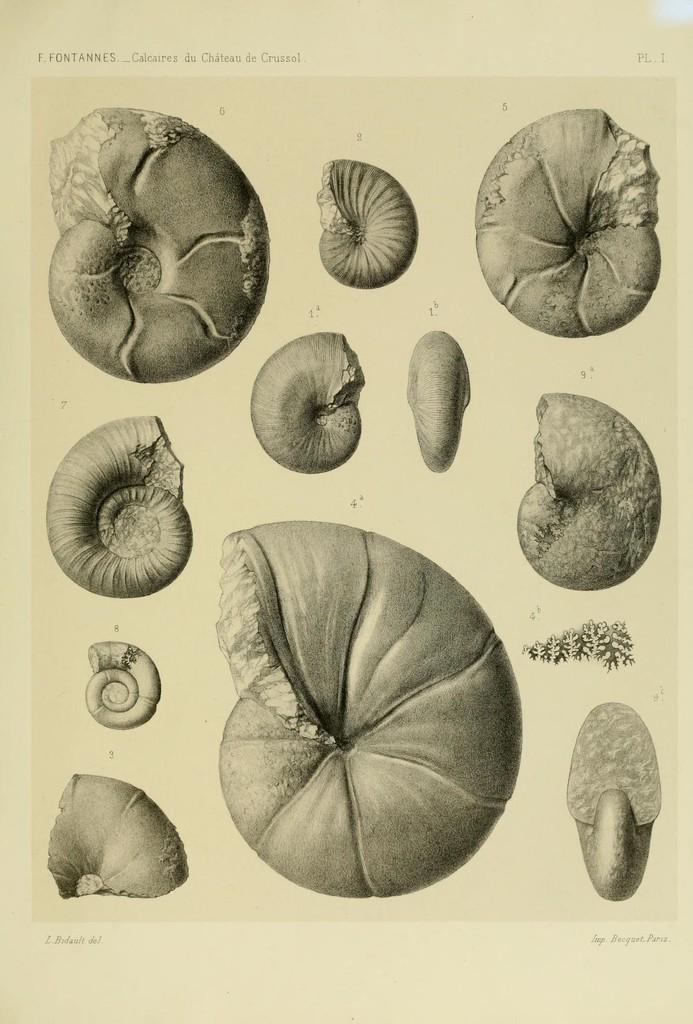Can you describe this image briefly? In this image I can see an art of few snail shells on the paper. 